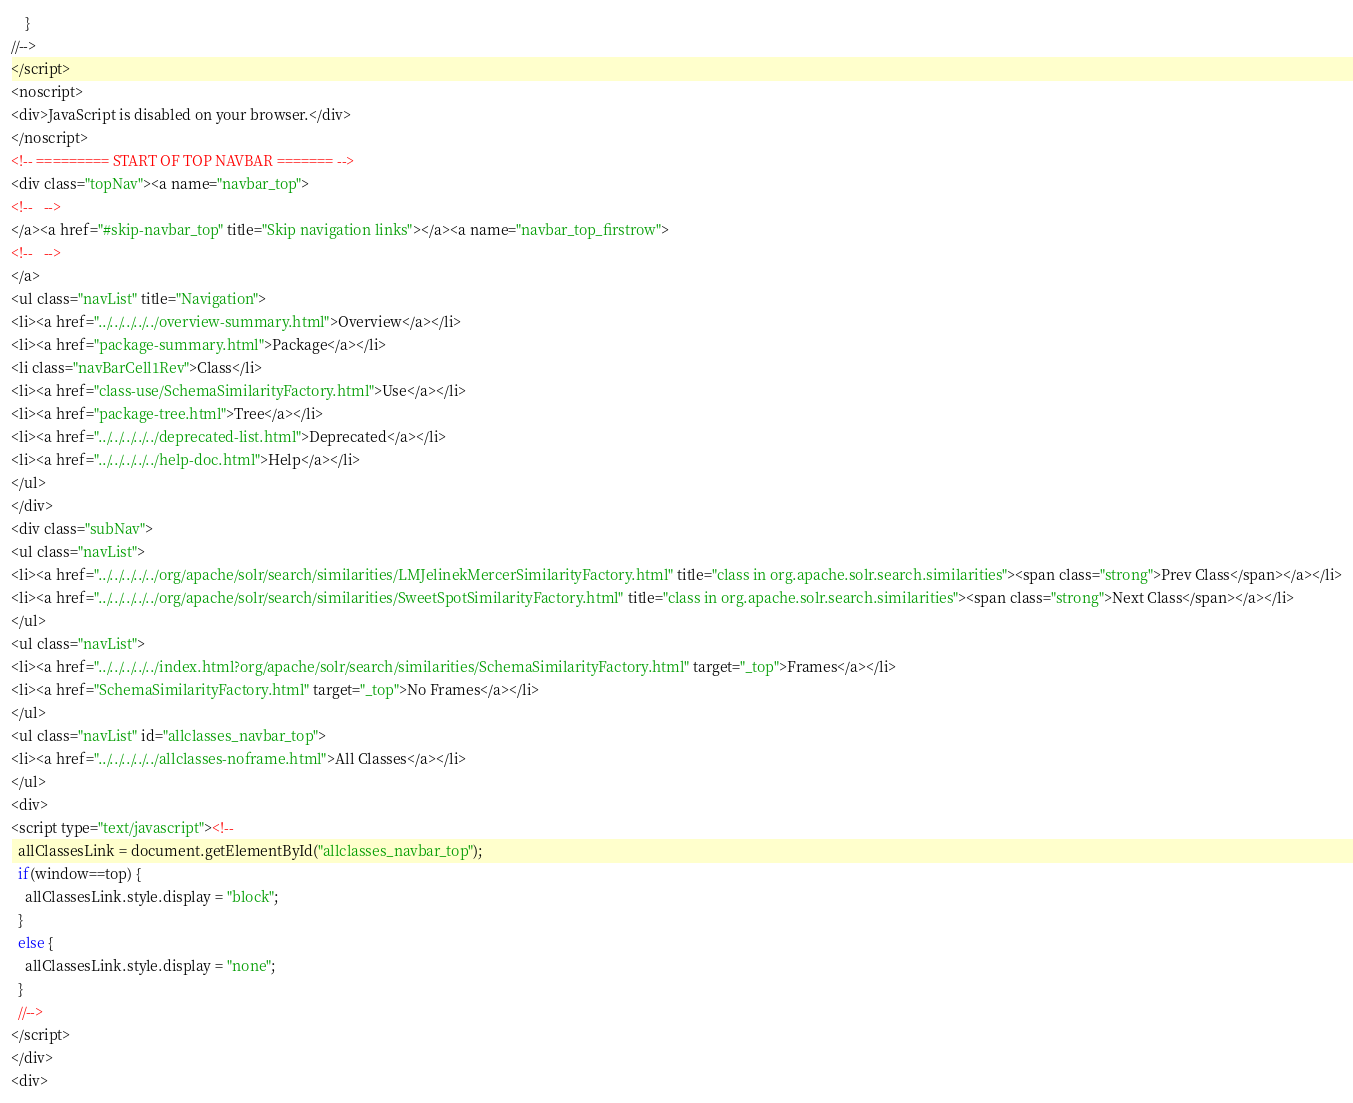<code> <loc_0><loc_0><loc_500><loc_500><_HTML_>    }
//-->
</script>
<noscript>
<div>JavaScript is disabled on your browser.</div>
</noscript>
<!-- ========= START OF TOP NAVBAR ======= -->
<div class="topNav"><a name="navbar_top">
<!--   -->
</a><a href="#skip-navbar_top" title="Skip navigation links"></a><a name="navbar_top_firstrow">
<!--   -->
</a>
<ul class="navList" title="Navigation">
<li><a href="../../../../../overview-summary.html">Overview</a></li>
<li><a href="package-summary.html">Package</a></li>
<li class="navBarCell1Rev">Class</li>
<li><a href="class-use/SchemaSimilarityFactory.html">Use</a></li>
<li><a href="package-tree.html">Tree</a></li>
<li><a href="../../../../../deprecated-list.html">Deprecated</a></li>
<li><a href="../../../../../help-doc.html">Help</a></li>
</ul>
</div>
<div class="subNav">
<ul class="navList">
<li><a href="../../../../../org/apache/solr/search/similarities/LMJelinekMercerSimilarityFactory.html" title="class in org.apache.solr.search.similarities"><span class="strong">Prev Class</span></a></li>
<li><a href="../../../../../org/apache/solr/search/similarities/SweetSpotSimilarityFactory.html" title="class in org.apache.solr.search.similarities"><span class="strong">Next Class</span></a></li>
</ul>
<ul class="navList">
<li><a href="../../../../../index.html?org/apache/solr/search/similarities/SchemaSimilarityFactory.html" target="_top">Frames</a></li>
<li><a href="SchemaSimilarityFactory.html" target="_top">No Frames</a></li>
</ul>
<ul class="navList" id="allclasses_navbar_top">
<li><a href="../../../../../allclasses-noframe.html">All Classes</a></li>
</ul>
<div>
<script type="text/javascript"><!--
  allClassesLink = document.getElementById("allclasses_navbar_top");
  if(window==top) {
    allClassesLink.style.display = "block";
  }
  else {
    allClassesLink.style.display = "none";
  }
  //-->
</script>
</div>
<div></code> 